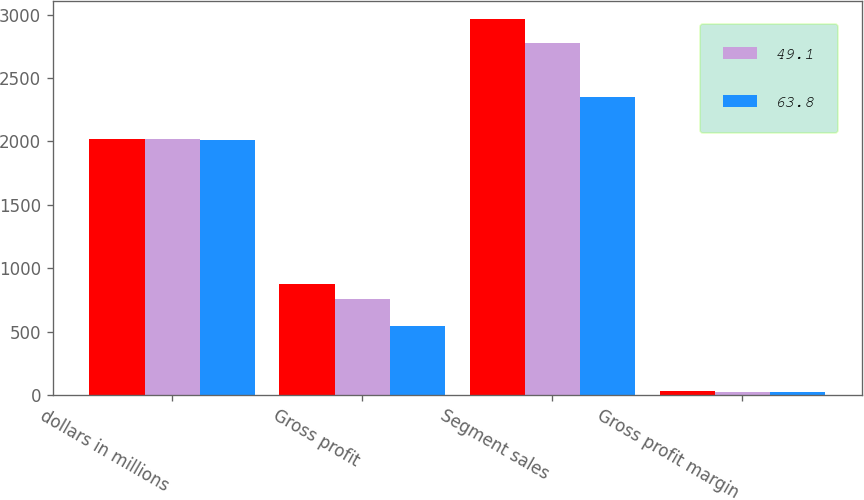Convert chart to OTSL. <chart><loc_0><loc_0><loc_500><loc_500><stacked_bar_chart><ecel><fcel>dollars in millions<fcel>Gross profit<fcel>Segment sales<fcel>Gross profit margin<nl><fcel>nan<fcel>2016<fcel>873.1<fcel>2961.8<fcel>29.5<nl><fcel>49.1<fcel>2015<fcel>755.7<fcel>2777.8<fcel>27.2<nl><fcel>63.8<fcel>2014<fcel>544.1<fcel>2346.4<fcel>23.2<nl></chart> 